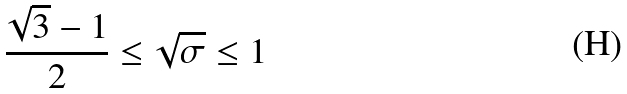Convert formula to latex. <formula><loc_0><loc_0><loc_500><loc_500>\frac { \sqrt { 3 } - 1 } { 2 } \leq \sqrt { \sigma } \leq 1</formula> 